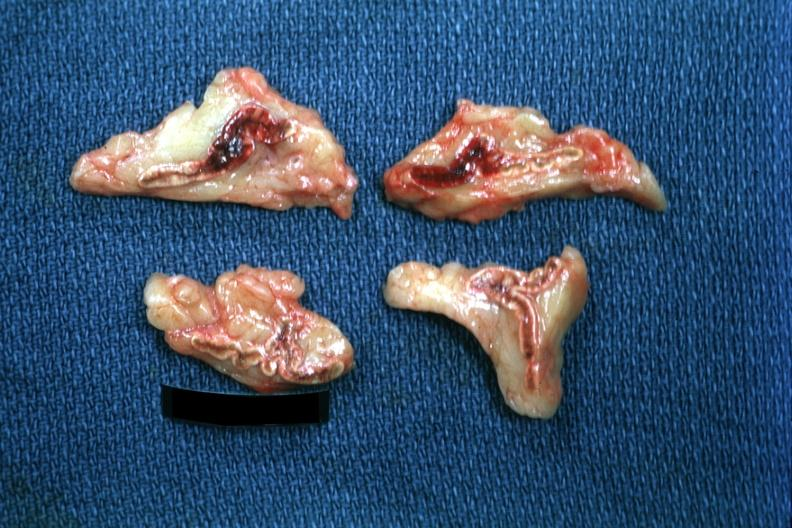why does this image show cortical and medullary hemorrhage not extensive but clearly evident case of pneumococcal meningitis lesion probably?
Answer the question using a single word or phrase. Due to septic shock 